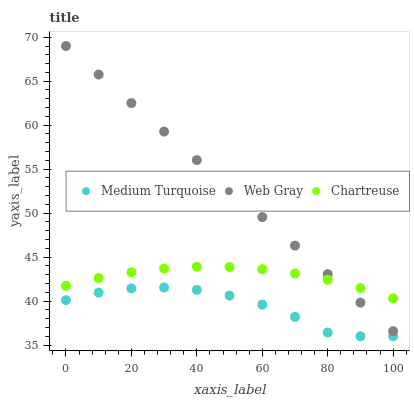Does Medium Turquoise have the minimum area under the curve?
Answer yes or no. Yes. Does Web Gray have the maximum area under the curve?
Answer yes or no. Yes. Does Web Gray have the minimum area under the curve?
Answer yes or no. No. Does Medium Turquoise have the maximum area under the curve?
Answer yes or no. No. Is Web Gray the smoothest?
Answer yes or no. Yes. Is Medium Turquoise the roughest?
Answer yes or no. Yes. Is Medium Turquoise the smoothest?
Answer yes or no. No. Is Web Gray the roughest?
Answer yes or no. No. Does Medium Turquoise have the lowest value?
Answer yes or no. Yes. Does Web Gray have the lowest value?
Answer yes or no. No. Does Web Gray have the highest value?
Answer yes or no. Yes. Does Medium Turquoise have the highest value?
Answer yes or no. No. Is Medium Turquoise less than Chartreuse?
Answer yes or no. Yes. Is Chartreuse greater than Medium Turquoise?
Answer yes or no. Yes. Does Web Gray intersect Chartreuse?
Answer yes or no. Yes. Is Web Gray less than Chartreuse?
Answer yes or no. No. Is Web Gray greater than Chartreuse?
Answer yes or no. No. Does Medium Turquoise intersect Chartreuse?
Answer yes or no. No. 